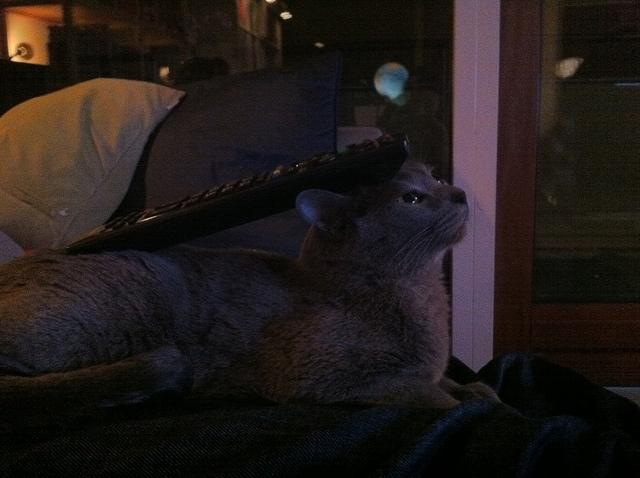What kind of animal is shown?
Short answer required. Cat. Is it in the morning?
Keep it brief. No. What is the cat's color?
Keep it brief. Gray. What is the primary color of the chair?
Quick response, please. Gray. Is it daytime?
Write a very short answer. No. Where is the cat looking at?
Concise answer only. Tv. Where is the cat looking?
Answer briefly. Up. Is this a tabby cat?
Short answer required. No. What is the cat looking at?
Keep it brief. Television. Is there anything edible in this photo?
Short answer required. No. Is there a remote next to the cat?
Answer briefly. Yes. Is the animal you see looking through the window a dog or a cat?
Quick response, please. Cat. Is the cat scared?
Answer briefly. No. 